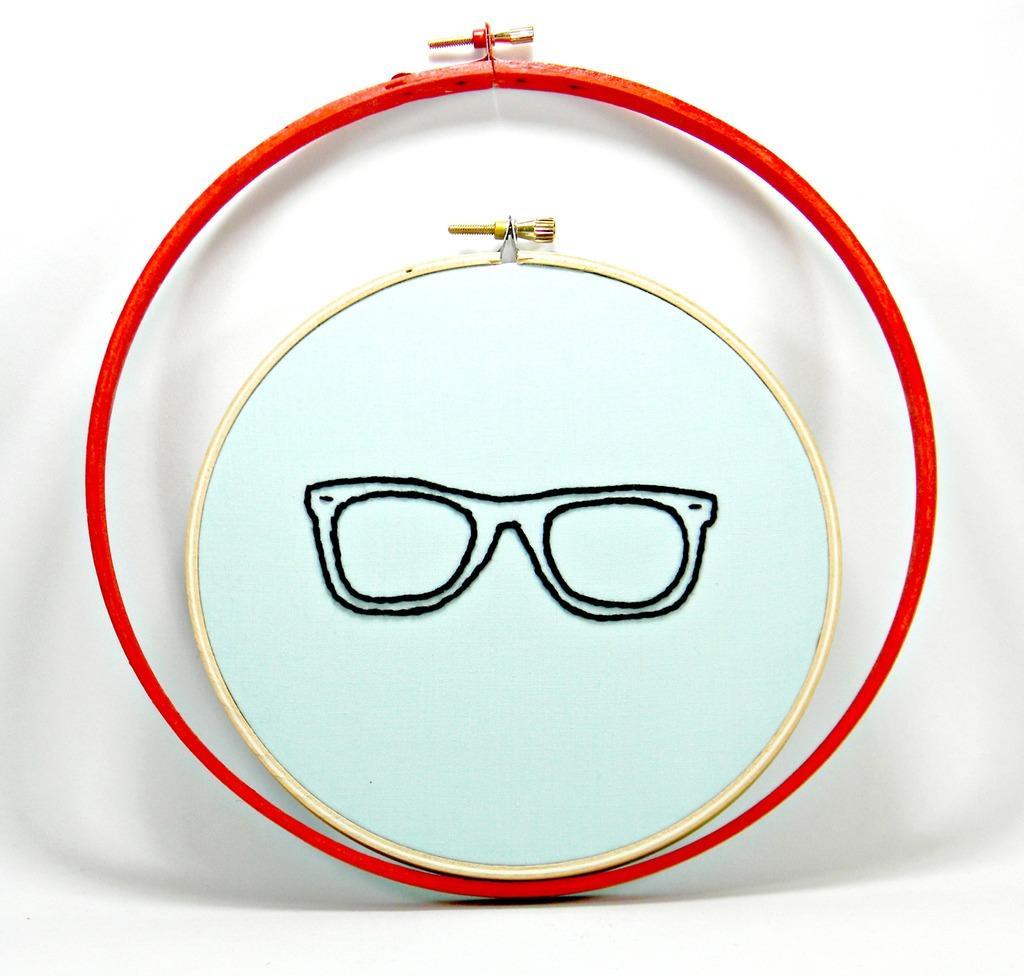How would you summarize this image in a sentence or two? In this image I can see two circular things and I can see one is of red and another one is of cream colour. I can also see depiction of shades over here and in the background I can see white colour. 